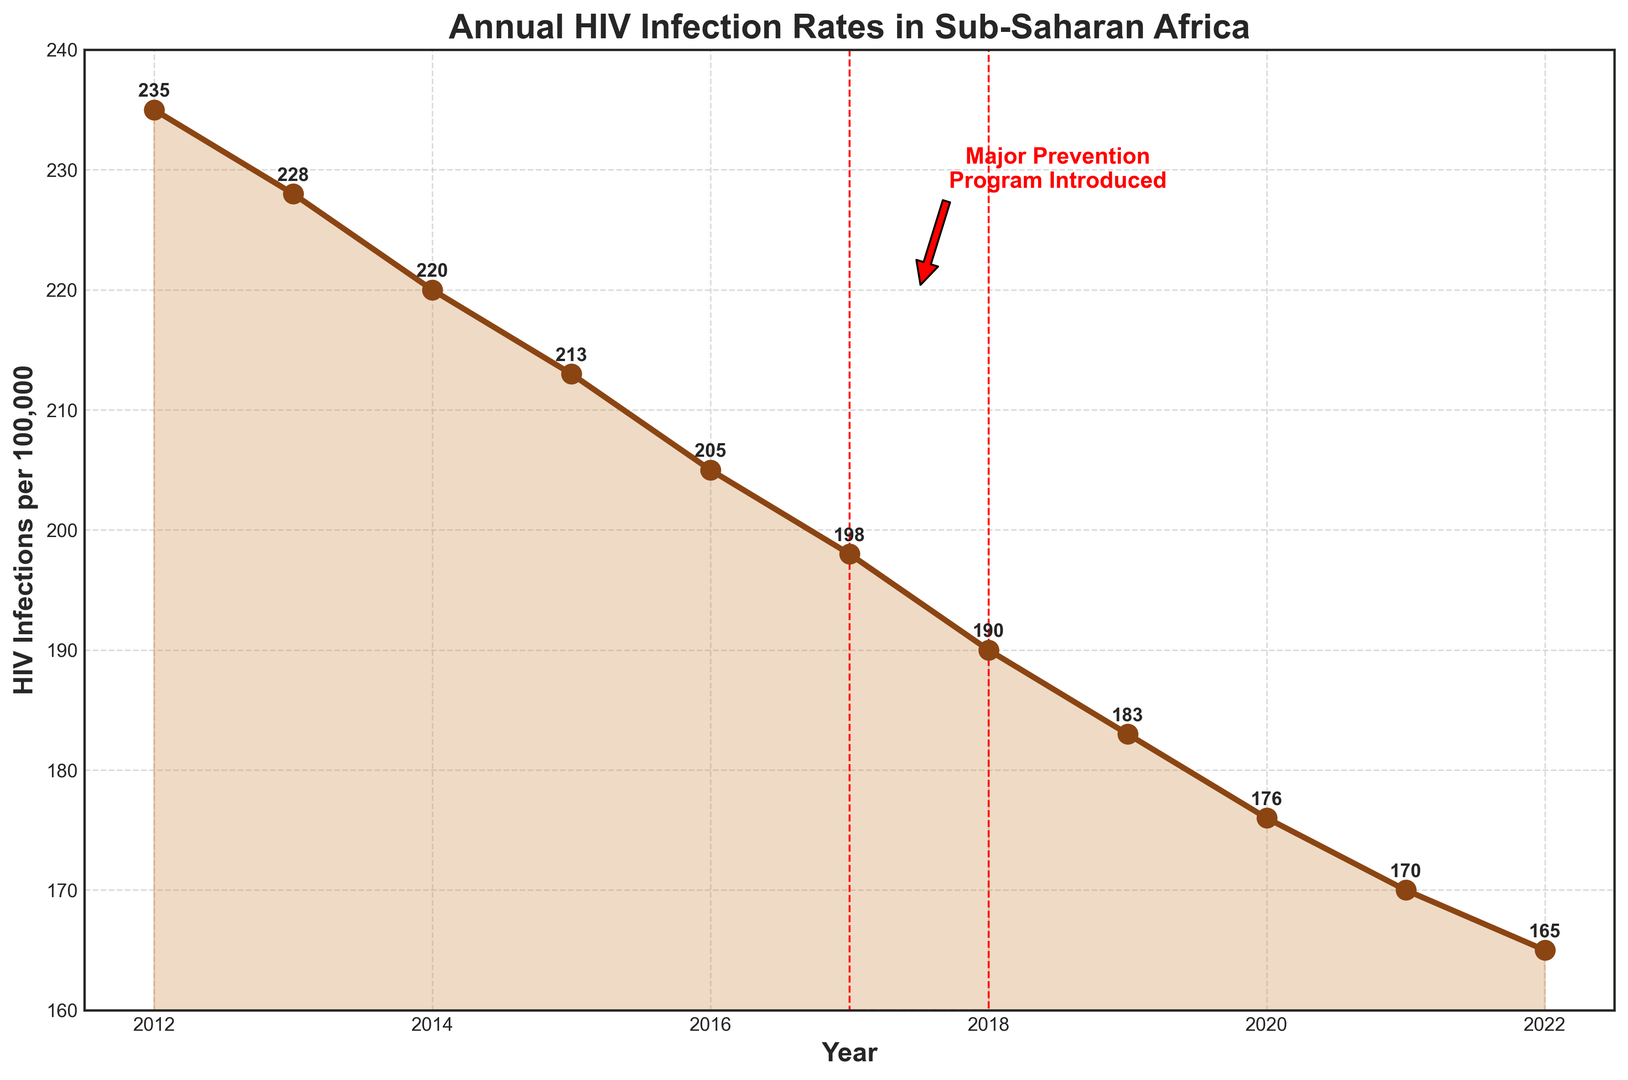What is the overall trend in annual HIV infection rates in sub-Saharan Africa from 2012 to 2022? The figure shows a downward trend in annual HIV infection rates from 235 infections per 100,000 in 2012 to 165 infections per 100,000 in 2022. Each year, the rate decreases gradually.
Answer: Downward trend Which year marks the introduction of the major prevention program? The major prevention program is noted with an annotation and a red rectangle around the year 2017.
Answer: 2017 What is the rate of HIV infections per 100,000 in the year 2017? The plot includes labeled data points, showing that the HIV infection rate for 2017 is 198 infections per 100,000.
Answer: 198 By how many infections per 100,000 did the HIV rate decrease from 2017 to 2022? To find the decrease, subtract the 2022 rate from the 2017 rate: 198 (2017) - 165 (2022) = 33.
Answer: 33 Compare the HIV infection rates in 2015 and 2016. Which year had a lower rate, and by how much? The infection rate in 2015 is 213 per 100,000 and in 2016 is 205 per 100,000. Thus, 2016 had a lower rate by 213 - 205 = 8 per 100,000.
Answer: 2016, by 8 What is the average annual HIV infection rate from 2012 to 2016? Add the rates for each year from 2012 to 2016 and divide by the number of years: (235 + 228 + 220 + 213 + 205) / 5 = 220.2.
Answer: 220.2 What visual features are used to highlight the introduction of the major prevention program? The introduction of the major prevention program is highlighted with a red rectangle around the year 2017 and a red annotation stating "Major Prevention Program Introduced" with an arrow pointing to 2017.
Answer: Red rectangle and annotation What is the percentage decrease in HIV infection rates from 2012 to 2022? First, calculate the absolute decrease: 235 - 165 = 70. Then, calculate the percentage decrease: (70 / 235) * 100 ≈ 29.79%.
Answer: 29.79% What was the rate of reduction in infections per 100,000 between 2013 and 2014? Subtract the infection rate of 2014 from that of 2013: 228 - 220 = 8 infections per 100,000.
Answer: 8 How do the changes in infection rates before and after the introduction of the major prevention program compare? Before the program (2012-2016), the rate decreased from 235 to 205, a difference of 30 over 5 years, averaging 6 per year. After the program (2017-2022), the rate dropped from 198 to 165, a difference of 33 over 5 years, averaging 6.6 per year. Thus, the annual rate of decrease slightly improved.
Answer: Slightly improved after 2017 